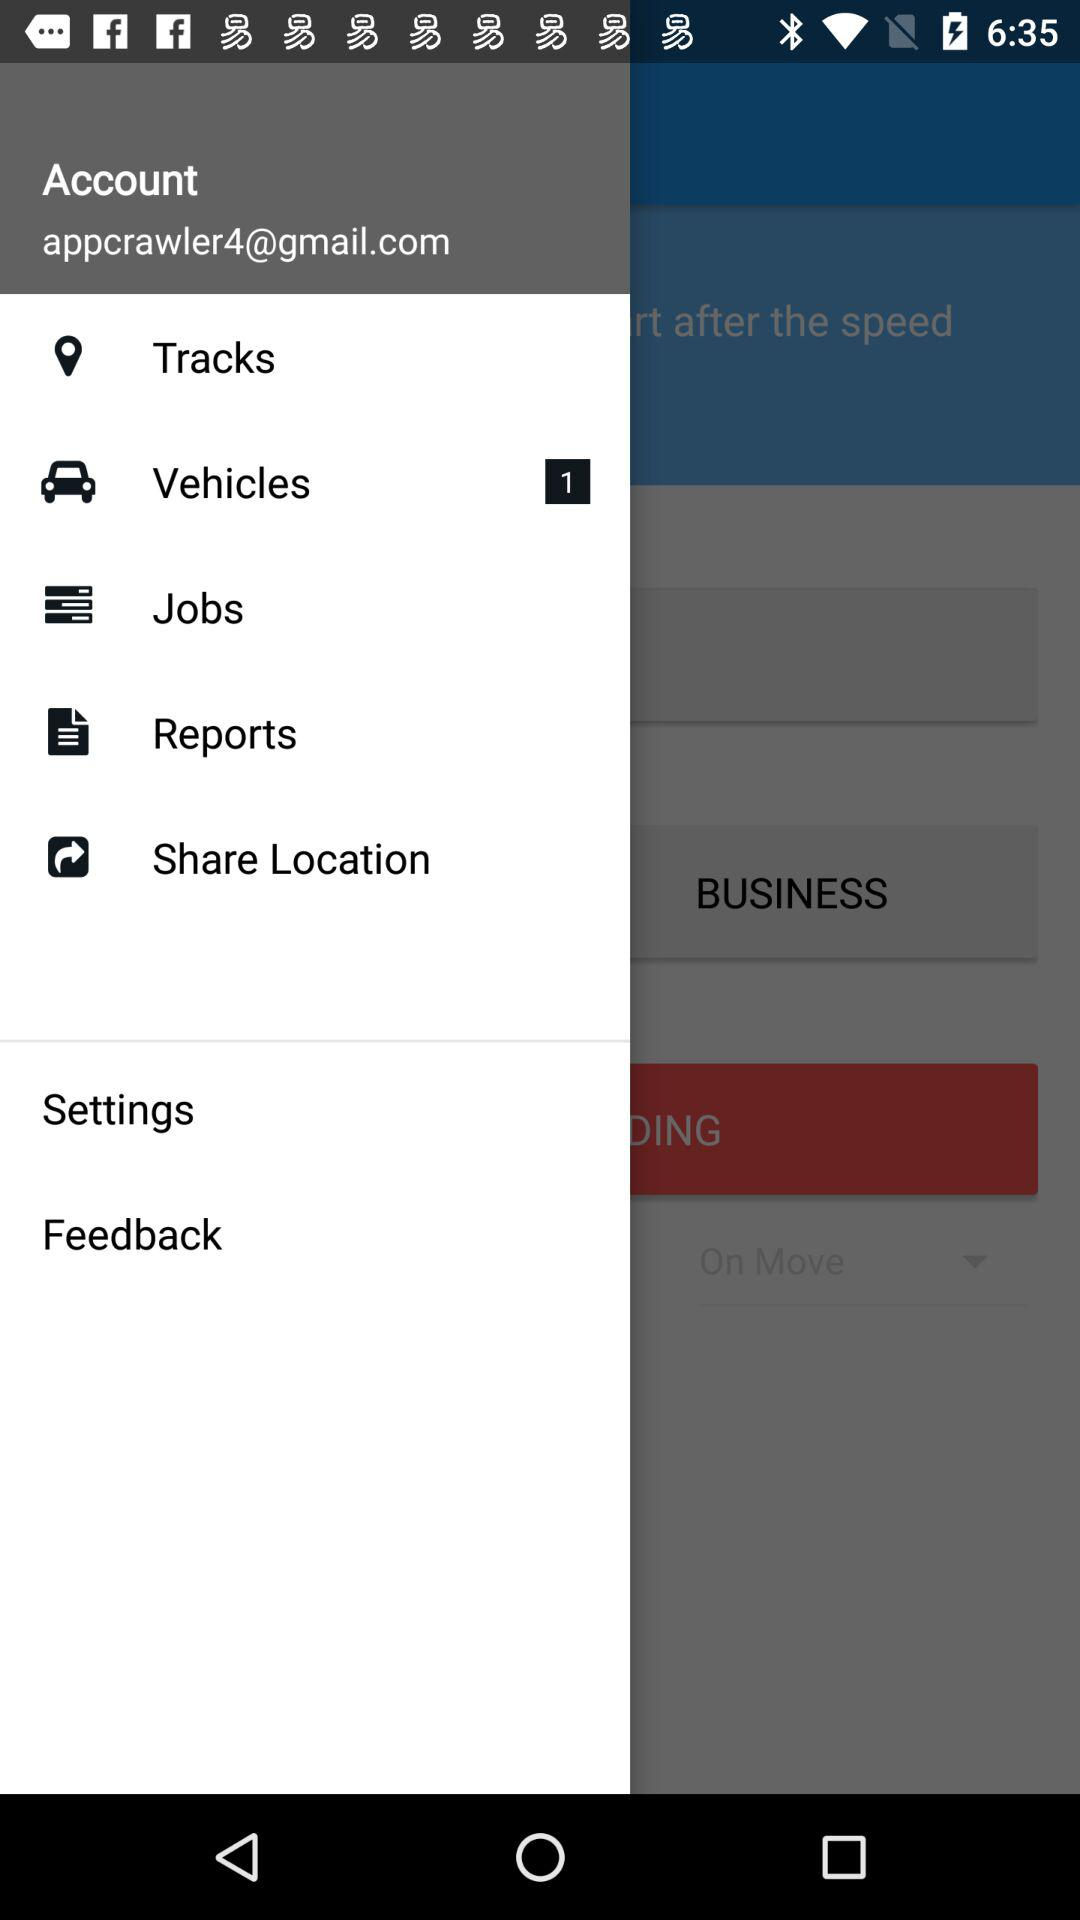What is the email address? The email address is appcrawler4@gmail.com. 